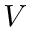<formula> <loc_0><loc_0><loc_500><loc_500>V</formula> 